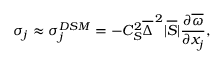<formula> <loc_0><loc_0><loc_500><loc_500>\sigma _ { j } \approx \sigma _ { j } ^ { D S M } = - C _ { S } ^ { 2 } \overline { \Delta } ^ { \, 2 } | \overline { S } | \frac { \partial \overline { \omega } } { \partial x _ { j } } ,</formula> 